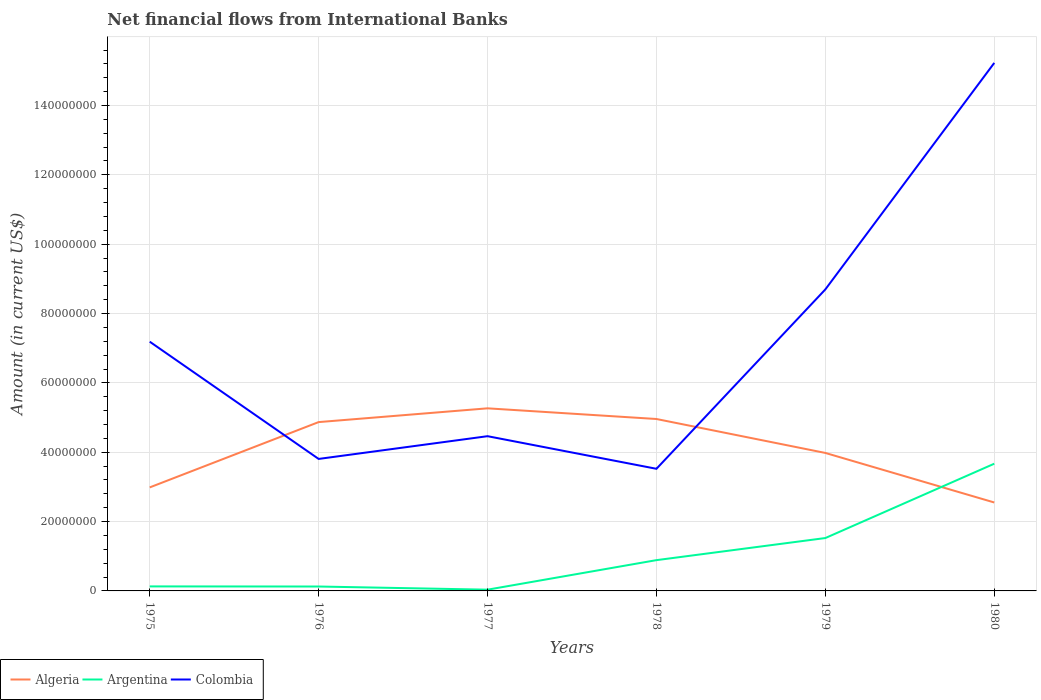Across all years, what is the maximum net financial aid flows in Argentina?
Provide a succinct answer. 3.61e+05. In which year was the net financial aid flows in Algeria maximum?
Your response must be concise. 1980. What is the total net financial aid flows in Algeria in the graph?
Your answer should be compact. 1.29e+07. What is the difference between the highest and the second highest net financial aid flows in Colombia?
Ensure brevity in your answer.  1.17e+08. What is the difference between the highest and the lowest net financial aid flows in Argentina?
Keep it short and to the point. 2. Is the net financial aid flows in Colombia strictly greater than the net financial aid flows in Algeria over the years?
Keep it short and to the point. No. How many lines are there?
Give a very brief answer. 3. How many years are there in the graph?
Provide a short and direct response. 6. What is the difference between two consecutive major ticks on the Y-axis?
Provide a short and direct response. 2.00e+07. Are the values on the major ticks of Y-axis written in scientific E-notation?
Ensure brevity in your answer.  No. Does the graph contain grids?
Provide a short and direct response. Yes. How are the legend labels stacked?
Make the answer very short. Horizontal. What is the title of the graph?
Give a very brief answer. Net financial flows from International Banks. Does "New Zealand" appear as one of the legend labels in the graph?
Offer a terse response. No. What is the Amount (in current US$) in Algeria in 1975?
Your response must be concise. 2.99e+07. What is the Amount (in current US$) of Argentina in 1975?
Offer a terse response. 1.30e+06. What is the Amount (in current US$) in Colombia in 1975?
Make the answer very short. 7.19e+07. What is the Amount (in current US$) in Algeria in 1976?
Ensure brevity in your answer.  4.87e+07. What is the Amount (in current US$) in Argentina in 1976?
Your response must be concise. 1.27e+06. What is the Amount (in current US$) in Colombia in 1976?
Offer a terse response. 3.81e+07. What is the Amount (in current US$) in Algeria in 1977?
Provide a short and direct response. 5.27e+07. What is the Amount (in current US$) in Argentina in 1977?
Keep it short and to the point. 3.61e+05. What is the Amount (in current US$) of Colombia in 1977?
Your response must be concise. 4.46e+07. What is the Amount (in current US$) in Algeria in 1978?
Provide a short and direct response. 4.96e+07. What is the Amount (in current US$) of Argentina in 1978?
Your response must be concise. 8.88e+06. What is the Amount (in current US$) of Colombia in 1978?
Offer a terse response. 3.52e+07. What is the Amount (in current US$) of Algeria in 1979?
Your answer should be very brief. 3.98e+07. What is the Amount (in current US$) in Argentina in 1979?
Provide a short and direct response. 1.53e+07. What is the Amount (in current US$) in Colombia in 1979?
Offer a terse response. 8.70e+07. What is the Amount (in current US$) in Algeria in 1980?
Offer a very short reply. 2.55e+07. What is the Amount (in current US$) in Argentina in 1980?
Keep it short and to the point. 3.67e+07. What is the Amount (in current US$) of Colombia in 1980?
Your answer should be compact. 1.52e+08. Across all years, what is the maximum Amount (in current US$) of Algeria?
Offer a terse response. 5.27e+07. Across all years, what is the maximum Amount (in current US$) in Argentina?
Provide a short and direct response. 3.67e+07. Across all years, what is the maximum Amount (in current US$) of Colombia?
Give a very brief answer. 1.52e+08. Across all years, what is the minimum Amount (in current US$) in Algeria?
Make the answer very short. 2.55e+07. Across all years, what is the minimum Amount (in current US$) of Argentina?
Offer a very short reply. 3.61e+05. Across all years, what is the minimum Amount (in current US$) of Colombia?
Keep it short and to the point. 3.52e+07. What is the total Amount (in current US$) in Algeria in the graph?
Give a very brief answer. 2.46e+08. What is the total Amount (in current US$) in Argentina in the graph?
Ensure brevity in your answer.  6.38e+07. What is the total Amount (in current US$) in Colombia in the graph?
Offer a very short reply. 4.29e+08. What is the difference between the Amount (in current US$) in Algeria in 1975 and that in 1976?
Offer a very short reply. -1.88e+07. What is the difference between the Amount (in current US$) in Argentina in 1975 and that in 1976?
Offer a terse response. 3.20e+04. What is the difference between the Amount (in current US$) in Colombia in 1975 and that in 1976?
Provide a short and direct response. 3.38e+07. What is the difference between the Amount (in current US$) of Algeria in 1975 and that in 1977?
Your answer should be compact. -2.28e+07. What is the difference between the Amount (in current US$) of Argentina in 1975 and that in 1977?
Your answer should be compact. 9.40e+05. What is the difference between the Amount (in current US$) of Colombia in 1975 and that in 1977?
Give a very brief answer. 2.73e+07. What is the difference between the Amount (in current US$) in Algeria in 1975 and that in 1978?
Your answer should be compact. -1.97e+07. What is the difference between the Amount (in current US$) of Argentina in 1975 and that in 1978?
Offer a terse response. -7.58e+06. What is the difference between the Amount (in current US$) of Colombia in 1975 and that in 1978?
Your answer should be very brief. 3.67e+07. What is the difference between the Amount (in current US$) in Algeria in 1975 and that in 1979?
Provide a short and direct response. -9.94e+06. What is the difference between the Amount (in current US$) in Argentina in 1975 and that in 1979?
Ensure brevity in your answer.  -1.40e+07. What is the difference between the Amount (in current US$) of Colombia in 1975 and that in 1979?
Make the answer very short. -1.51e+07. What is the difference between the Amount (in current US$) of Algeria in 1975 and that in 1980?
Make the answer very short. 4.35e+06. What is the difference between the Amount (in current US$) in Argentina in 1975 and that in 1980?
Your response must be concise. -3.54e+07. What is the difference between the Amount (in current US$) in Colombia in 1975 and that in 1980?
Provide a succinct answer. -8.04e+07. What is the difference between the Amount (in current US$) in Algeria in 1976 and that in 1977?
Your answer should be compact. -3.97e+06. What is the difference between the Amount (in current US$) in Argentina in 1976 and that in 1977?
Offer a very short reply. 9.08e+05. What is the difference between the Amount (in current US$) of Colombia in 1976 and that in 1977?
Give a very brief answer. -6.56e+06. What is the difference between the Amount (in current US$) of Algeria in 1976 and that in 1978?
Make the answer very short. -8.91e+05. What is the difference between the Amount (in current US$) of Argentina in 1976 and that in 1978?
Your answer should be very brief. -7.61e+06. What is the difference between the Amount (in current US$) of Colombia in 1976 and that in 1978?
Your answer should be compact. 2.85e+06. What is the difference between the Amount (in current US$) in Algeria in 1976 and that in 1979?
Provide a short and direct response. 8.90e+06. What is the difference between the Amount (in current US$) of Argentina in 1976 and that in 1979?
Provide a succinct answer. -1.40e+07. What is the difference between the Amount (in current US$) in Colombia in 1976 and that in 1979?
Keep it short and to the point. -4.89e+07. What is the difference between the Amount (in current US$) of Algeria in 1976 and that in 1980?
Ensure brevity in your answer.  2.32e+07. What is the difference between the Amount (in current US$) in Argentina in 1976 and that in 1980?
Offer a terse response. -3.54e+07. What is the difference between the Amount (in current US$) of Colombia in 1976 and that in 1980?
Keep it short and to the point. -1.14e+08. What is the difference between the Amount (in current US$) of Algeria in 1977 and that in 1978?
Give a very brief answer. 3.08e+06. What is the difference between the Amount (in current US$) of Argentina in 1977 and that in 1978?
Offer a terse response. -8.52e+06. What is the difference between the Amount (in current US$) in Colombia in 1977 and that in 1978?
Keep it short and to the point. 9.41e+06. What is the difference between the Amount (in current US$) of Algeria in 1977 and that in 1979?
Your answer should be very brief. 1.29e+07. What is the difference between the Amount (in current US$) in Argentina in 1977 and that in 1979?
Offer a terse response. -1.49e+07. What is the difference between the Amount (in current US$) of Colombia in 1977 and that in 1979?
Your response must be concise. -4.23e+07. What is the difference between the Amount (in current US$) of Algeria in 1977 and that in 1980?
Keep it short and to the point. 2.72e+07. What is the difference between the Amount (in current US$) in Argentina in 1977 and that in 1980?
Keep it short and to the point. -3.63e+07. What is the difference between the Amount (in current US$) in Colombia in 1977 and that in 1980?
Your answer should be compact. -1.08e+08. What is the difference between the Amount (in current US$) in Algeria in 1978 and that in 1979?
Give a very brief answer. 9.79e+06. What is the difference between the Amount (in current US$) in Argentina in 1978 and that in 1979?
Your response must be concise. -6.37e+06. What is the difference between the Amount (in current US$) in Colombia in 1978 and that in 1979?
Ensure brevity in your answer.  -5.17e+07. What is the difference between the Amount (in current US$) of Algeria in 1978 and that in 1980?
Your answer should be compact. 2.41e+07. What is the difference between the Amount (in current US$) in Argentina in 1978 and that in 1980?
Your answer should be very brief. -2.78e+07. What is the difference between the Amount (in current US$) in Colombia in 1978 and that in 1980?
Your answer should be compact. -1.17e+08. What is the difference between the Amount (in current US$) of Algeria in 1979 and that in 1980?
Keep it short and to the point. 1.43e+07. What is the difference between the Amount (in current US$) in Argentina in 1979 and that in 1980?
Ensure brevity in your answer.  -2.14e+07. What is the difference between the Amount (in current US$) of Colombia in 1979 and that in 1980?
Keep it short and to the point. -6.53e+07. What is the difference between the Amount (in current US$) in Algeria in 1975 and the Amount (in current US$) in Argentina in 1976?
Provide a short and direct response. 2.86e+07. What is the difference between the Amount (in current US$) in Algeria in 1975 and the Amount (in current US$) in Colombia in 1976?
Make the answer very short. -8.21e+06. What is the difference between the Amount (in current US$) of Argentina in 1975 and the Amount (in current US$) of Colombia in 1976?
Your response must be concise. -3.68e+07. What is the difference between the Amount (in current US$) of Algeria in 1975 and the Amount (in current US$) of Argentina in 1977?
Your answer should be very brief. 2.95e+07. What is the difference between the Amount (in current US$) of Algeria in 1975 and the Amount (in current US$) of Colombia in 1977?
Keep it short and to the point. -1.48e+07. What is the difference between the Amount (in current US$) in Argentina in 1975 and the Amount (in current US$) in Colombia in 1977?
Make the answer very short. -4.33e+07. What is the difference between the Amount (in current US$) in Algeria in 1975 and the Amount (in current US$) in Argentina in 1978?
Provide a succinct answer. 2.10e+07. What is the difference between the Amount (in current US$) of Algeria in 1975 and the Amount (in current US$) of Colombia in 1978?
Your answer should be compact. -5.37e+06. What is the difference between the Amount (in current US$) in Argentina in 1975 and the Amount (in current US$) in Colombia in 1978?
Keep it short and to the point. -3.39e+07. What is the difference between the Amount (in current US$) of Algeria in 1975 and the Amount (in current US$) of Argentina in 1979?
Give a very brief answer. 1.46e+07. What is the difference between the Amount (in current US$) of Algeria in 1975 and the Amount (in current US$) of Colombia in 1979?
Offer a terse response. -5.71e+07. What is the difference between the Amount (in current US$) of Argentina in 1975 and the Amount (in current US$) of Colombia in 1979?
Provide a short and direct response. -8.57e+07. What is the difference between the Amount (in current US$) of Algeria in 1975 and the Amount (in current US$) of Argentina in 1980?
Your answer should be very brief. -6.84e+06. What is the difference between the Amount (in current US$) in Algeria in 1975 and the Amount (in current US$) in Colombia in 1980?
Offer a terse response. -1.22e+08. What is the difference between the Amount (in current US$) in Argentina in 1975 and the Amount (in current US$) in Colombia in 1980?
Your response must be concise. -1.51e+08. What is the difference between the Amount (in current US$) in Algeria in 1976 and the Amount (in current US$) in Argentina in 1977?
Provide a short and direct response. 4.83e+07. What is the difference between the Amount (in current US$) of Algeria in 1976 and the Amount (in current US$) of Colombia in 1977?
Offer a terse response. 4.06e+06. What is the difference between the Amount (in current US$) of Argentina in 1976 and the Amount (in current US$) of Colombia in 1977?
Your response must be concise. -4.34e+07. What is the difference between the Amount (in current US$) of Algeria in 1976 and the Amount (in current US$) of Argentina in 1978?
Make the answer very short. 3.98e+07. What is the difference between the Amount (in current US$) of Algeria in 1976 and the Amount (in current US$) of Colombia in 1978?
Provide a short and direct response. 1.35e+07. What is the difference between the Amount (in current US$) in Argentina in 1976 and the Amount (in current US$) in Colombia in 1978?
Your response must be concise. -3.40e+07. What is the difference between the Amount (in current US$) in Algeria in 1976 and the Amount (in current US$) in Argentina in 1979?
Provide a succinct answer. 3.34e+07. What is the difference between the Amount (in current US$) in Algeria in 1976 and the Amount (in current US$) in Colombia in 1979?
Keep it short and to the point. -3.83e+07. What is the difference between the Amount (in current US$) of Argentina in 1976 and the Amount (in current US$) of Colombia in 1979?
Offer a very short reply. -8.57e+07. What is the difference between the Amount (in current US$) in Algeria in 1976 and the Amount (in current US$) in Argentina in 1980?
Provide a short and direct response. 1.20e+07. What is the difference between the Amount (in current US$) of Algeria in 1976 and the Amount (in current US$) of Colombia in 1980?
Your answer should be compact. -1.04e+08. What is the difference between the Amount (in current US$) of Argentina in 1976 and the Amount (in current US$) of Colombia in 1980?
Your response must be concise. -1.51e+08. What is the difference between the Amount (in current US$) in Algeria in 1977 and the Amount (in current US$) in Argentina in 1978?
Your answer should be compact. 4.38e+07. What is the difference between the Amount (in current US$) in Algeria in 1977 and the Amount (in current US$) in Colombia in 1978?
Your answer should be very brief. 1.74e+07. What is the difference between the Amount (in current US$) in Argentina in 1977 and the Amount (in current US$) in Colombia in 1978?
Keep it short and to the point. -3.49e+07. What is the difference between the Amount (in current US$) of Algeria in 1977 and the Amount (in current US$) of Argentina in 1979?
Give a very brief answer. 3.74e+07. What is the difference between the Amount (in current US$) of Algeria in 1977 and the Amount (in current US$) of Colombia in 1979?
Keep it short and to the point. -3.43e+07. What is the difference between the Amount (in current US$) in Argentina in 1977 and the Amount (in current US$) in Colombia in 1979?
Provide a short and direct response. -8.66e+07. What is the difference between the Amount (in current US$) of Algeria in 1977 and the Amount (in current US$) of Argentina in 1980?
Offer a terse response. 1.60e+07. What is the difference between the Amount (in current US$) of Algeria in 1977 and the Amount (in current US$) of Colombia in 1980?
Offer a very short reply. -9.96e+07. What is the difference between the Amount (in current US$) in Argentina in 1977 and the Amount (in current US$) in Colombia in 1980?
Ensure brevity in your answer.  -1.52e+08. What is the difference between the Amount (in current US$) of Algeria in 1978 and the Amount (in current US$) of Argentina in 1979?
Ensure brevity in your answer.  3.43e+07. What is the difference between the Amount (in current US$) in Algeria in 1978 and the Amount (in current US$) in Colombia in 1979?
Your response must be concise. -3.74e+07. What is the difference between the Amount (in current US$) in Argentina in 1978 and the Amount (in current US$) in Colombia in 1979?
Your response must be concise. -7.81e+07. What is the difference between the Amount (in current US$) in Algeria in 1978 and the Amount (in current US$) in Argentina in 1980?
Keep it short and to the point. 1.29e+07. What is the difference between the Amount (in current US$) in Algeria in 1978 and the Amount (in current US$) in Colombia in 1980?
Provide a short and direct response. -1.03e+08. What is the difference between the Amount (in current US$) in Argentina in 1978 and the Amount (in current US$) in Colombia in 1980?
Offer a very short reply. -1.43e+08. What is the difference between the Amount (in current US$) of Algeria in 1979 and the Amount (in current US$) of Argentina in 1980?
Keep it short and to the point. 3.10e+06. What is the difference between the Amount (in current US$) of Algeria in 1979 and the Amount (in current US$) of Colombia in 1980?
Offer a terse response. -1.12e+08. What is the difference between the Amount (in current US$) in Argentina in 1979 and the Amount (in current US$) in Colombia in 1980?
Give a very brief answer. -1.37e+08. What is the average Amount (in current US$) of Algeria per year?
Your response must be concise. 4.10e+07. What is the average Amount (in current US$) in Argentina per year?
Provide a short and direct response. 1.06e+07. What is the average Amount (in current US$) of Colombia per year?
Provide a succinct answer. 7.15e+07. In the year 1975, what is the difference between the Amount (in current US$) of Algeria and Amount (in current US$) of Argentina?
Give a very brief answer. 2.86e+07. In the year 1975, what is the difference between the Amount (in current US$) in Algeria and Amount (in current US$) in Colombia?
Your response must be concise. -4.20e+07. In the year 1975, what is the difference between the Amount (in current US$) of Argentina and Amount (in current US$) of Colombia?
Provide a short and direct response. -7.06e+07. In the year 1976, what is the difference between the Amount (in current US$) of Algeria and Amount (in current US$) of Argentina?
Give a very brief answer. 4.74e+07. In the year 1976, what is the difference between the Amount (in current US$) in Algeria and Amount (in current US$) in Colombia?
Offer a very short reply. 1.06e+07. In the year 1976, what is the difference between the Amount (in current US$) of Argentina and Amount (in current US$) of Colombia?
Provide a short and direct response. -3.68e+07. In the year 1977, what is the difference between the Amount (in current US$) of Algeria and Amount (in current US$) of Argentina?
Offer a terse response. 5.23e+07. In the year 1977, what is the difference between the Amount (in current US$) in Algeria and Amount (in current US$) in Colombia?
Give a very brief answer. 8.04e+06. In the year 1977, what is the difference between the Amount (in current US$) in Argentina and Amount (in current US$) in Colombia?
Offer a very short reply. -4.43e+07. In the year 1978, what is the difference between the Amount (in current US$) of Algeria and Amount (in current US$) of Argentina?
Keep it short and to the point. 4.07e+07. In the year 1978, what is the difference between the Amount (in current US$) in Algeria and Amount (in current US$) in Colombia?
Ensure brevity in your answer.  1.44e+07. In the year 1978, what is the difference between the Amount (in current US$) of Argentina and Amount (in current US$) of Colombia?
Your answer should be compact. -2.63e+07. In the year 1979, what is the difference between the Amount (in current US$) in Algeria and Amount (in current US$) in Argentina?
Offer a terse response. 2.45e+07. In the year 1979, what is the difference between the Amount (in current US$) of Algeria and Amount (in current US$) of Colombia?
Offer a terse response. -4.72e+07. In the year 1979, what is the difference between the Amount (in current US$) of Argentina and Amount (in current US$) of Colombia?
Your answer should be compact. -7.17e+07. In the year 1980, what is the difference between the Amount (in current US$) of Algeria and Amount (in current US$) of Argentina?
Give a very brief answer. -1.12e+07. In the year 1980, what is the difference between the Amount (in current US$) in Algeria and Amount (in current US$) in Colombia?
Offer a terse response. -1.27e+08. In the year 1980, what is the difference between the Amount (in current US$) in Argentina and Amount (in current US$) in Colombia?
Offer a terse response. -1.16e+08. What is the ratio of the Amount (in current US$) in Algeria in 1975 to that in 1976?
Provide a short and direct response. 0.61. What is the ratio of the Amount (in current US$) of Argentina in 1975 to that in 1976?
Give a very brief answer. 1.03. What is the ratio of the Amount (in current US$) of Colombia in 1975 to that in 1976?
Your response must be concise. 1.89. What is the ratio of the Amount (in current US$) in Algeria in 1975 to that in 1977?
Your answer should be very brief. 0.57. What is the ratio of the Amount (in current US$) of Argentina in 1975 to that in 1977?
Your answer should be very brief. 3.6. What is the ratio of the Amount (in current US$) of Colombia in 1975 to that in 1977?
Your answer should be compact. 1.61. What is the ratio of the Amount (in current US$) in Algeria in 1975 to that in 1978?
Give a very brief answer. 0.6. What is the ratio of the Amount (in current US$) in Argentina in 1975 to that in 1978?
Your answer should be compact. 0.15. What is the ratio of the Amount (in current US$) in Colombia in 1975 to that in 1978?
Offer a terse response. 2.04. What is the ratio of the Amount (in current US$) of Algeria in 1975 to that in 1979?
Your answer should be compact. 0.75. What is the ratio of the Amount (in current US$) in Argentina in 1975 to that in 1979?
Your response must be concise. 0.09. What is the ratio of the Amount (in current US$) in Colombia in 1975 to that in 1979?
Your answer should be compact. 0.83. What is the ratio of the Amount (in current US$) of Algeria in 1975 to that in 1980?
Provide a short and direct response. 1.17. What is the ratio of the Amount (in current US$) in Argentina in 1975 to that in 1980?
Provide a succinct answer. 0.04. What is the ratio of the Amount (in current US$) in Colombia in 1975 to that in 1980?
Offer a terse response. 0.47. What is the ratio of the Amount (in current US$) of Algeria in 1976 to that in 1977?
Your answer should be very brief. 0.92. What is the ratio of the Amount (in current US$) in Argentina in 1976 to that in 1977?
Your answer should be very brief. 3.52. What is the ratio of the Amount (in current US$) in Colombia in 1976 to that in 1977?
Ensure brevity in your answer.  0.85. What is the ratio of the Amount (in current US$) of Argentina in 1976 to that in 1978?
Make the answer very short. 0.14. What is the ratio of the Amount (in current US$) in Colombia in 1976 to that in 1978?
Offer a very short reply. 1.08. What is the ratio of the Amount (in current US$) of Algeria in 1976 to that in 1979?
Offer a very short reply. 1.22. What is the ratio of the Amount (in current US$) of Argentina in 1976 to that in 1979?
Provide a succinct answer. 0.08. What is the ratio of the Amount (in current US$) of Colombia in 1976 to that in 1979?
Offer a very short reply. 0.44. What is the ratio of the Amount (in current US$) of Algeria in 1976 to that in 1980?
Offer a terse response. 1.91. What is the ratio of the Amount (in current US$) of Argentina in 1976 to that in 1980?
Keep it short and to the point. 0.03. What is the ratio of the Amount (in current US$) in Algeria in 1977 to that in 1978?
Ensure brevity in your answer.  1.06. What is the ratio of the Amount (in current US$) in Argentina in 1977 to that in 1978?
Your answer should be very brief. 0.04. What is the ratio of the Amount (in current US$) of Colombia in 1977 to that in 1978?
Keep it short and to the point. 1.27. What is the ratio of the Amount (in current US$) in Algeria in 1977 to that in 1979?
Give a very brief answer. 1.32. What is the ratio of the Amount (in current US$) of Argentina in 1977 to that in 1979?
Ensure brevity in your answer.  0.02. What is the ratio of the Amount (in current US$) in Colombia in 1977 to that in 1979?
Offer a terse response. 0.51. What is the ratio of the Amount (in current US$) in Algeria in 1977 to that in 1980?
Make the answer very short. 2.06. What is the ratio of the Amount (in current US$) in Argentina in 1977 to that in 1980?
Make the answer very short. 0.01. What is the ratio of the Amount (in current US$) in Colombia in 1977 to that in 1980?
Provide a succinct answer. 0.29. What is the ratio of the Amount (in current US$) in Algeria in 1978 to that in 1979?
Your answer should be very brief. 1.25. What is the ratio of the Amount (in current US$) in Argentina in 1978 to that in 1979?
Provide a succinct answer. 0.58. What is the ratio of the Amount (in current US$) in Colombia in 1978 to that in 1979?
Your answer should be very brief. 0.41. What is the ratio of the Amount (in current US$) in Algeria in 1978 to that in 1980?
Your response must be concise. 1.94. What is the ratio of the Amount (in current US$) in Argentina in 1978 to that in 1980?
Make the answer very short. 0.24. What is the ratio of the Amount (in current US$) in Colombia in 1978 to that in 1980?
Keep it short and to the point. 0.23. What is the ratio of the Amount (in current US$) in Algeria in 1979 to that in 1980?
Your answer should be very brief. 1.56. What is the ratio of the Amount (in current US$) of Argentina in 1979 to that in 1980?
Provide a succinct answer. 0.42. What is the ratio of the Amount (in current US$) in Colombia in 1979 to that in 1980?
Your answer should be compact. 0.57. What is the difference between the highest and the second highest Amount (in current US$) of Algeria?
Your response must be concise. 3.08e+06. What is the difference between the highest and the second highest Amount (in current US$) of Argentina?
Your answer should be very brief. 2.14e+07. What is the difference between the highest and the second highest Amount (in current US$) of Colombia?
Provide a short and direct response. 6.53e+07. What is the difference between the highest and the lowest Amount (in current US$) of Algeria?
Provide a short and direct response. 2.72e+07. What is the difference between the highest and the lowest Amount (in current US$) in Argentina?
Offer a terse response. 3.63e+07. What is the difference between the highest and the lowest Amount (in current US$) in Colombia?
Offer a very short reply. 1.17e+08. 